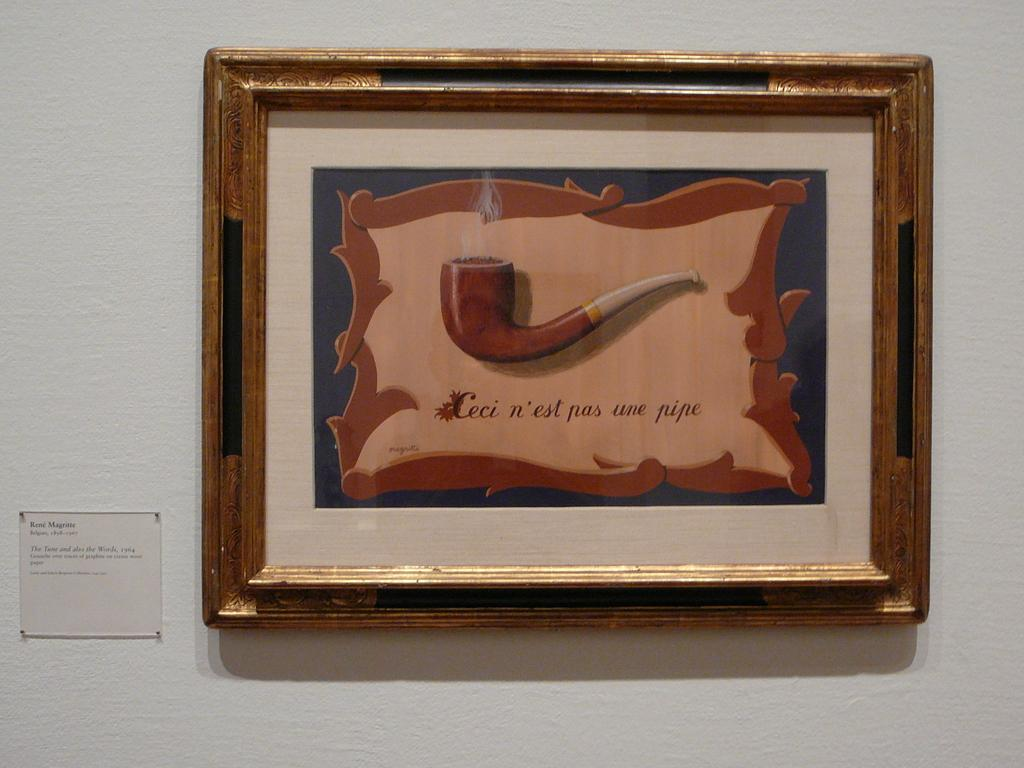<image>
Share a concise interpretation of the image provided. A wooden framed picture of a wooden smoking pipe with the tage name for Rene Magritte on the left. 